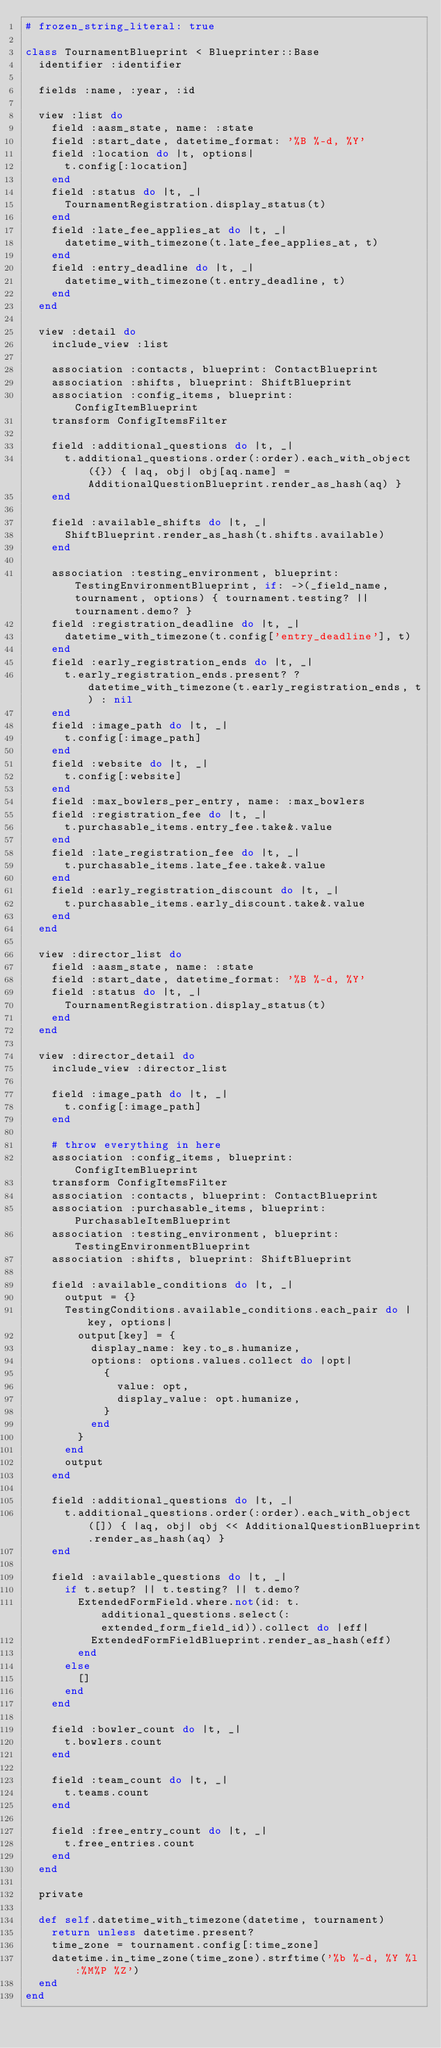<code> <loc_0><loc_0><loc_500><loc_500><_Ruby_># frozen_string_literal: true

class TournamentBlueprint < Blueprinter::Base
  identifier :identifier

  fields :name, :year, :id

  view :list do
    field :aasm_state, name: :state
    field :start_date, datetime_format: '%B %-d, %Y'
    field :location do |t, options|
      t.config[:location]
    end
    field :status do |t, _|
      TournamentRegistration.display_status(t)
    end
    field :late_fee_applies_at do |t, _|
      datetime_with_timezone(t.late_fee_applies_at, t)
    end
    field :entry_deadline do |t, _|
      datetime_with_timezone(t.entry_deadline, t)
    end
  end

  view :detail do
    include_view :list

    association :contacts, blueprint: ContactBlueprint
    association :shifts, blueprint: ShiftBlueprint
    association :config_items, blueprint: ConfigItemBlueprint
    transform ConfigItemsFilter

    field :additional_questions do |t, _|
      t.additional_questions.order(:order).each_with_object({}) { |aq, obj| obj[aq.name] = AdditionalQuestionBlueprint.render_as_hash(aq) }
    end

    field :available_shifts do |t, _|
      ShiftBlueprint.render_as_hash(t.shifts.available)
    end

    association :testing_environment, blueprint: TestingEnvironmentBlueprint, if: ->(_field_name, tournament, options) { tournament.testing? || tournament.demo? }
    field :registration_deadline do |t, _|
      datetime_with_timezone(t.config['entry_deadline'], t)
    end
    field :early_registration_ends do |t, _|
      t.early_registration_ends.present? ? datetime_with_timezone(t.early_registration_ends, t) : nil
    end
    field :image_path do |t, _|
      t.config[:image_path]
    end
    field :website do |t, _|
      t.config[:website]
    end
    field :max_bowlers_per_entry, name: :max_bowlers
    field :registration_fee do |t, _|
      t.purchasable_items.entry_fee.take&.value
    end
    field :late_registration_fee do |t, _|
      t.purchasable_items.late_fee.take&.value
    end
    field :early_registration_discount do |t, _|
      t.purchasable_items.early_discount.take&.value
    end
  end

  view :director_list do
    field :aasm_state, name: :state
    field :start_date, datetime_format: '%B %-d, %Y'
    field :status do |t, _|
      TournamentRegistration.display_status(t)
    end
  end

  view :director_detail do
    include_view :director_list

    field :image_path do |t, _|
      t.config[:image_path]
    end

    # throw everything in here
    association :config_items, blueprint: ConfigItemBlueprint
    transform ConfigItemsFilter
    association :contacts, blueprint: ContactBlueprint
    association :purchasable_items, blueprint: PurchasableItemBlueprint
    association :testing_environment, blueprint: TestingEnvironmentBlueprint
    association :shifts, blueprint: ShiftBlueprint

    field :available_conditions do |t, _|
      output = {}
      TestingConditions.available_conditions.each_pair do |key, options|
        output[key] = {
          display_name: key.to_s.humanize,
          options: options.values.collect do |opt|
            {
              value: opt,
              display_value: opt.humanize,
            }
          end
        }
      end
      output
    end

    field :additional_questions do |t, _|
      t.additional_questions.order(:order).each_with_object([]) { |aq, obj| obj << AdditionalQuestionBlueprint.render_as_hash(aq) }
    end

    field :available_questions do |t, _|
      if t.setup? || t.testing? || t.demo?
        ExtendedFormField.where.not(id: t.additional_questions.select(:extended_form_field_id)).collect do |eff|
          ExtendedFormFieldBlueprint.render_as_hash(eff)
        end
      else
        []
      end
    end

    field :bowler_count do |t, _|
      t.bowlers.count
    end

    field :team_count do |t, _|
      t.teams.count
    end

    field :free_entry_count do |t, _|
      t.free_entries.count
    end
  end

  private

  def self.datetime_with_timezone(datetime, tournament)
    return unless datetime.present?
    time_zone = tournament.config[:time_zone]
    datetime.in_time_zone(time_zone).strftime('%b %-d, %Y %l:%M%P %Z')
  end
end
</code> 